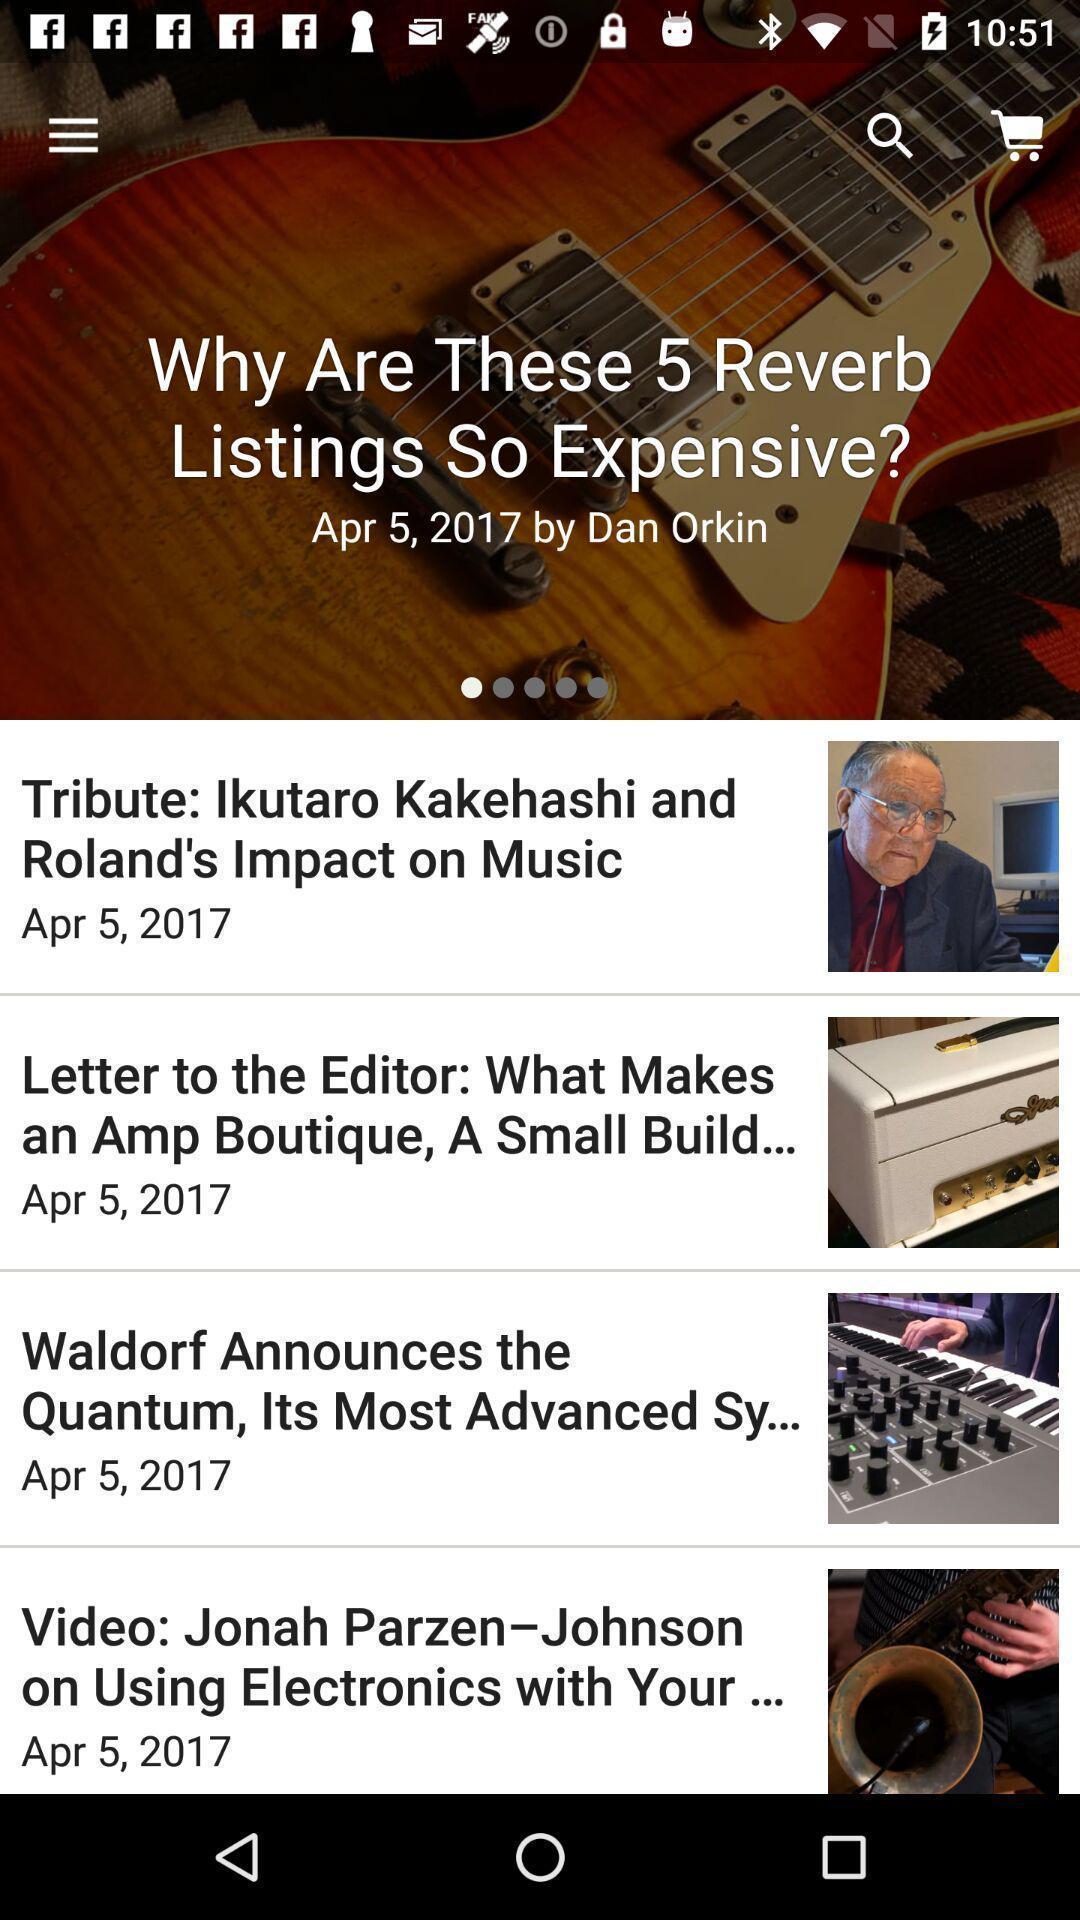Tell me what you see in this picture. Various news feed displayed. 